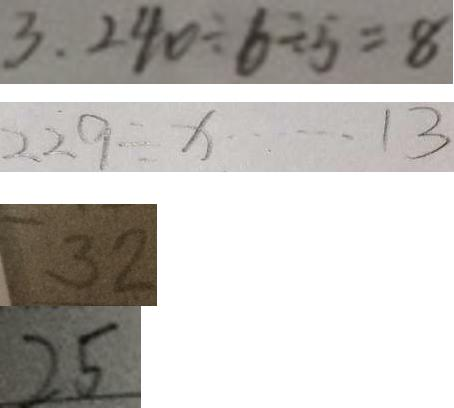Convert formula to latex. <formula><loc_0><loc_0><loc_500><loc_500>3 . 2 4 0 \div 6 \div 5 = 8 
 2 2 9 \div x \cdots 1 3 
 3 2 
 2 5</formula> 